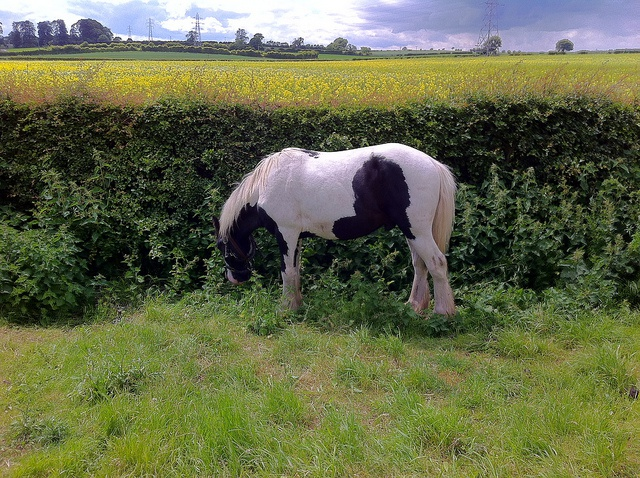Describe the objects in this image and their specific colors. I can see a horse in white, black, gray, and lavender tones in this image. 